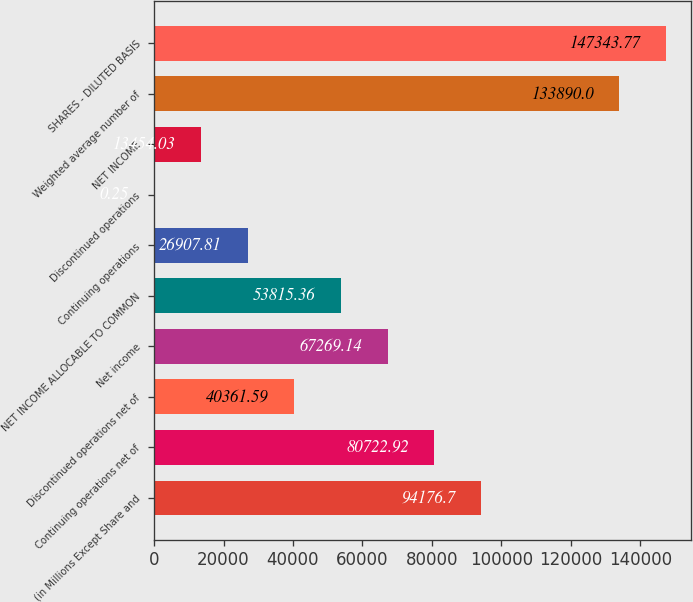Convert chart to OTSL. <chart><loc_0><loc_0><loc_500><loc_500><bar_chart><fcel>(in Millions Except Share and<fcel>Continuing operations net of<fcel>Discontinued operations net of<fcel>Net income<fcel>NET INCOME ALLOCABLE TO COMMON<fcel>Continuing operations<fcel>Discontinued operations<fcel>NET INCOME<fcel>Weighted average number of<fcel>SHARES - DILUTED BASIS<nl><fcel>94176.7<fcel>80722.9<fcel>40361.6<fcel>67269.1<fcel>53815.4<fcel>26907.8<fcel>0.25<fcel>13454<fcel>133890<fcel>147344<nl></chart> 